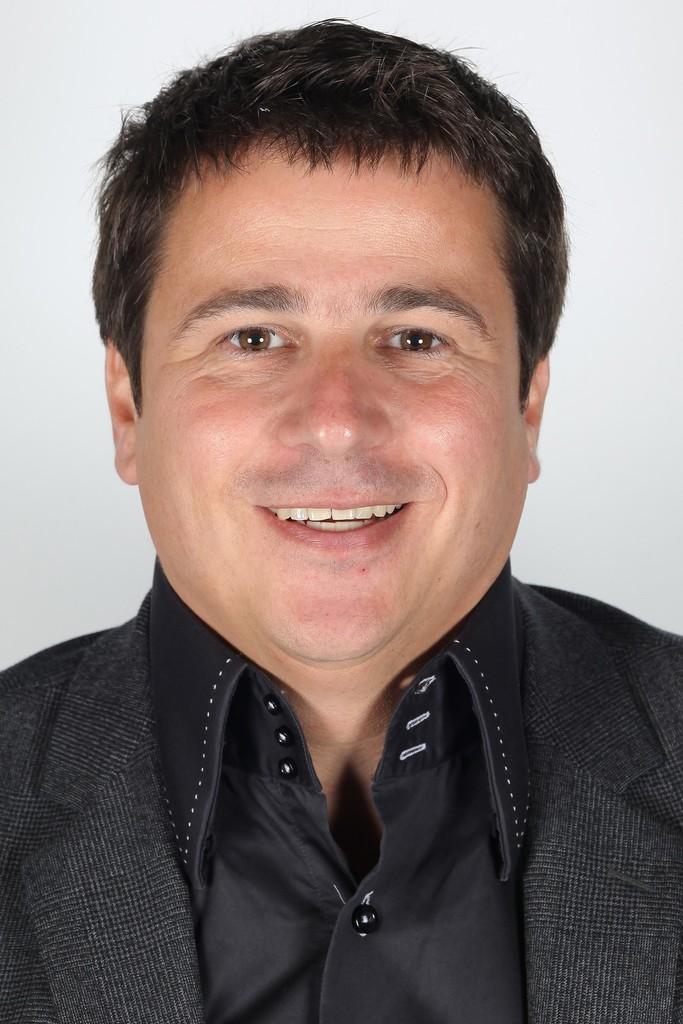In one or two sentences, can you explain what this image depicts? In this picture I can see there is a man standing here and he is smiling. He is wearing a black coat and a black shirt and in the backdrop there is a white surface. 